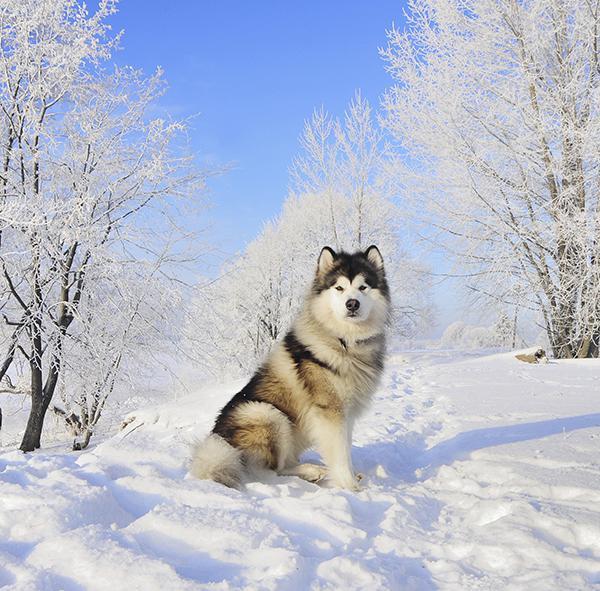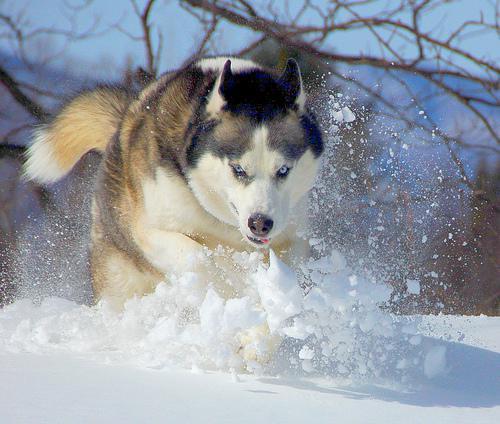The first image is the image on the left, the second image is the image on the right. For the images displayed, is the sentence "The left image shows a dog in some kind of reclining pose on a sofa, and the right image includes a husky dog outdoors on snow-covered ground." factually correct? Answer yes or no. No. The first image is the image on the left, the second image is the image on the right. For the images shown, is this caption "There are two dogs outside." true? Answer yes or no. Yes. 